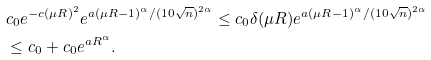Convert formula to latex. <formula><loc_0><loc_0><loc_500><loc_500>& c _ { 0 } e ^ { - c ( \mu R ) ^ { 2 } } e ^ { a ( \mu R - 1 ) ^ { \alpha } / ( 1 0 \sqrt { n } ) ^ { 2 \alpha } } \leq c _ { 0 } \delta ( \mu R ) e ^ { a ( \mu R - 1 ) ^ { \alpha } / ( 1 0 \sqrt { n } ) ^ { 2 \alpha } } \\ & \leq c _ { 0 } + c _ { 0 } e ^ { a R ^ { \alpha } } .</formula> 